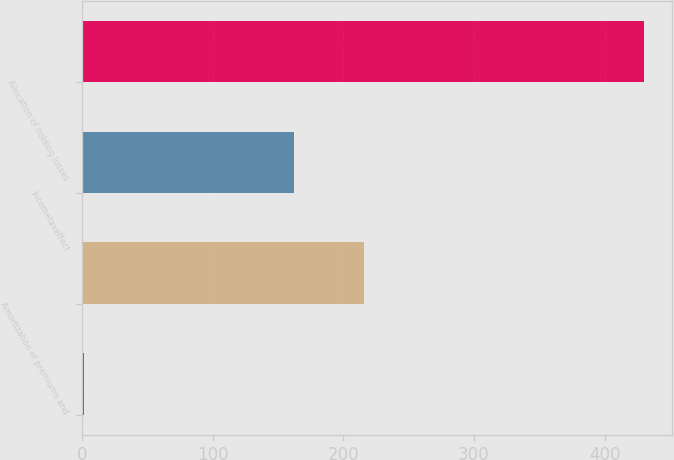<chart> <loc_0><loc_0><loc_500><loc_500><bar_chart><ecel><fcel>Amortization of premiums and<fcel>Incometaxeffect<fcel>Allocation of holding losses<nl><fcel>2<fcel>216<fcel>162.5<fcel>430<nl></chart> 